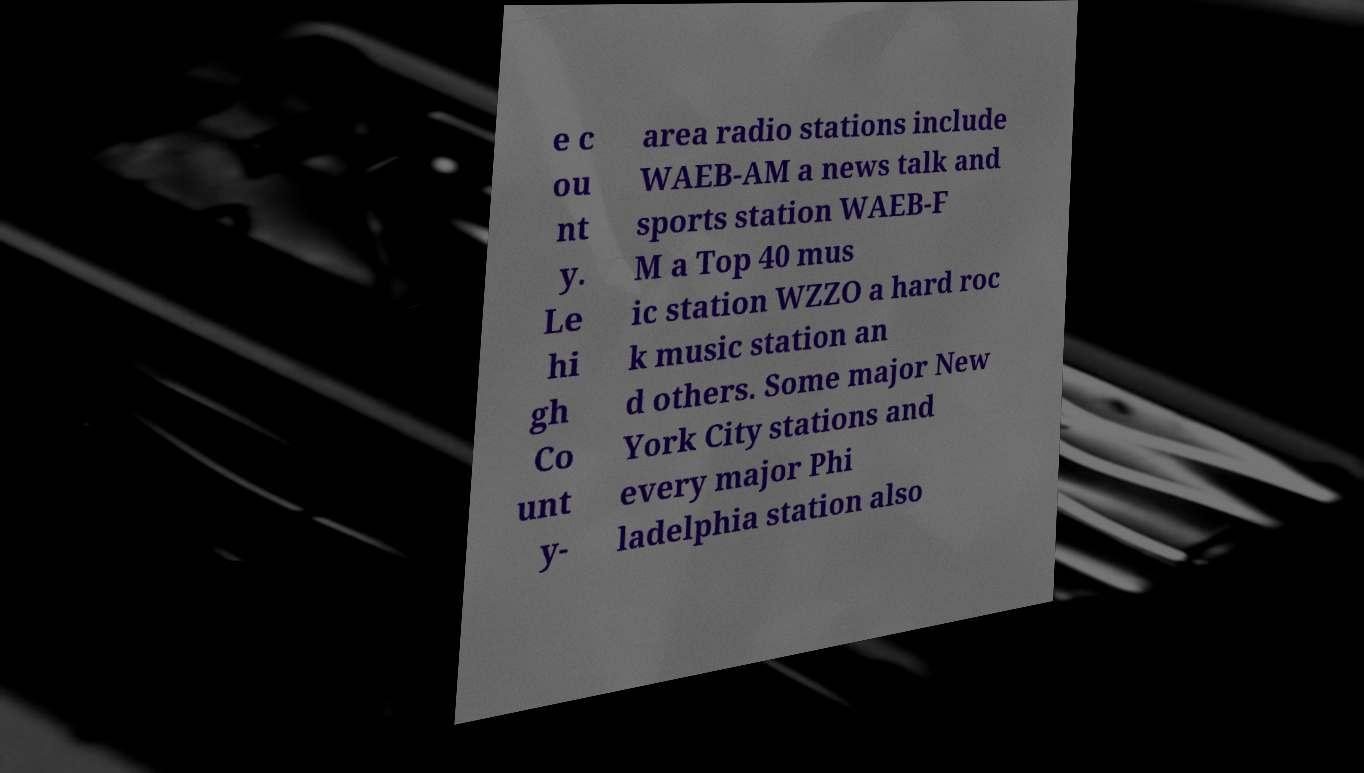Please read and relay the text visible in this image. What does it say? e c ou nt y. Le hi gh Co unt y- area radio stations include WAEB-AM a news talk and sports station WAEB-F M a Top 40 mus ic station WZZO a hard roc k music station an d others. Some major New York City stations and every major Phi ladelphia station also 